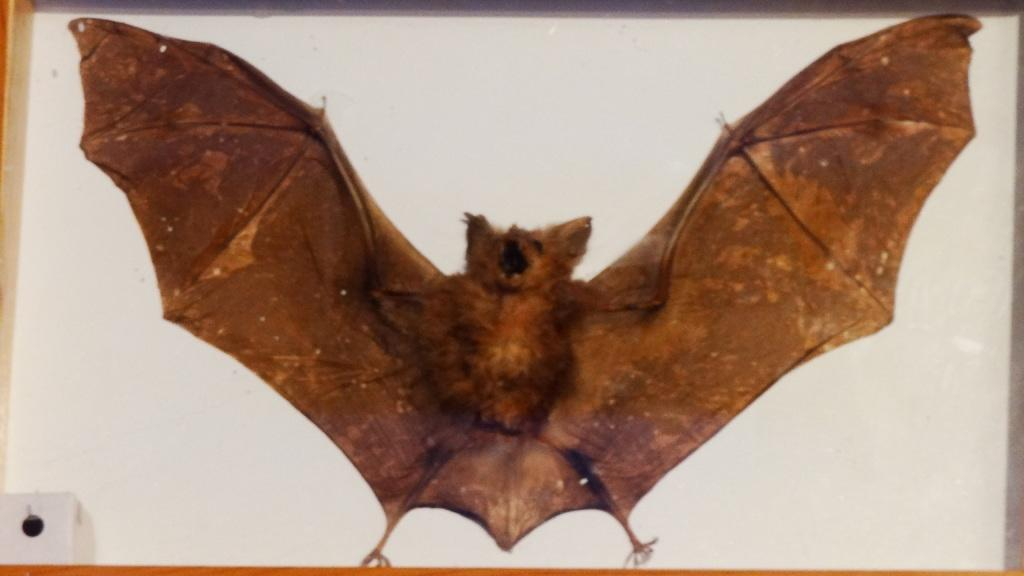What is the main subject in the center of the image? There is a bat in the center of the image. What type of offer is being made by the bat in the image? There is no offer being made by the bat in the image, as it is an animal and cannot make offers. 